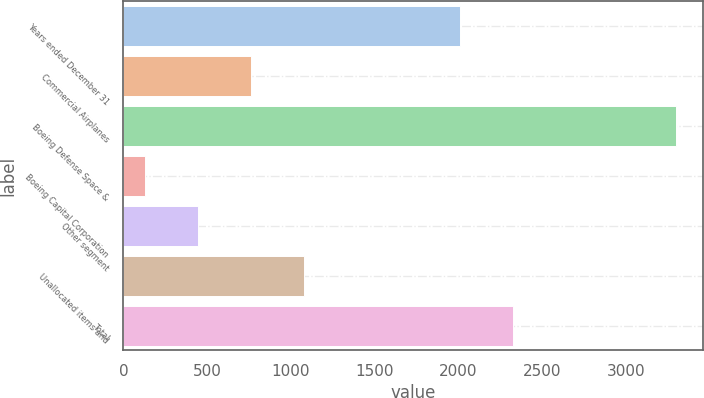<chart> <loc_0><loc_0><loc_500><loc_500><bar_chart><fcel>Years ended December 31<fcel>Commercial Airplanes<fcel>Boeing Defense Space &<fcel>Boeing Capital Corporation<fcel>Other segment<fcel>Unallocated items and<fcel>Total<nl><fcel>2009<fcel>760.6<fcel>3299<fcel>126<fcel>443.3<fcel>1077.9<fcel>2326.3<nl></chart> 